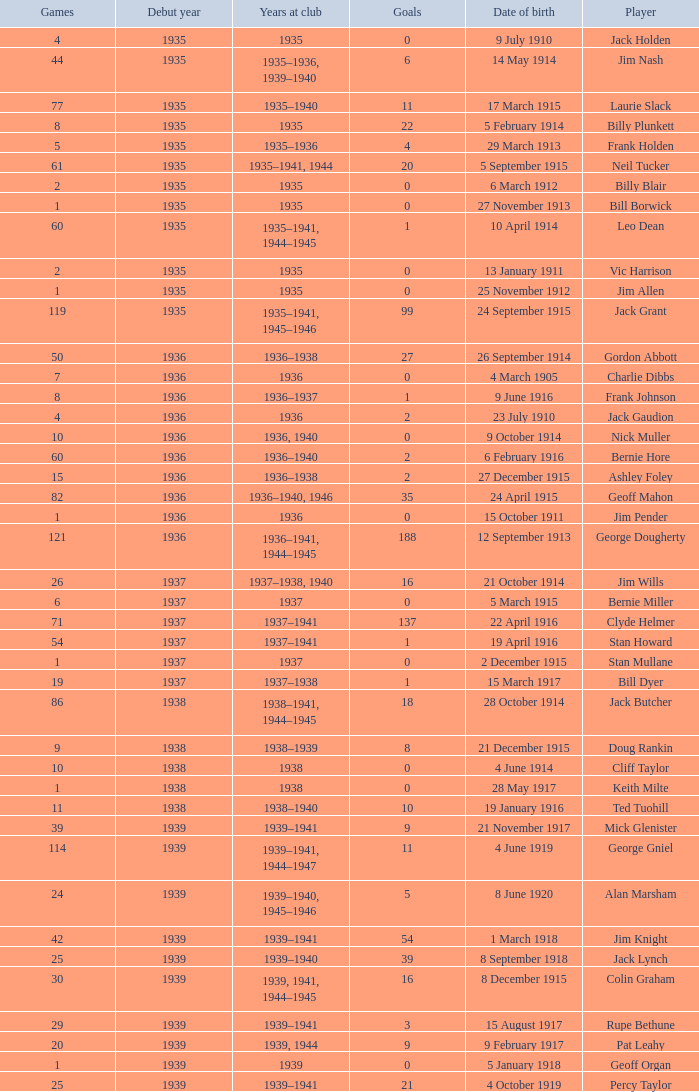How many games had 22 goals before 1935? None. 